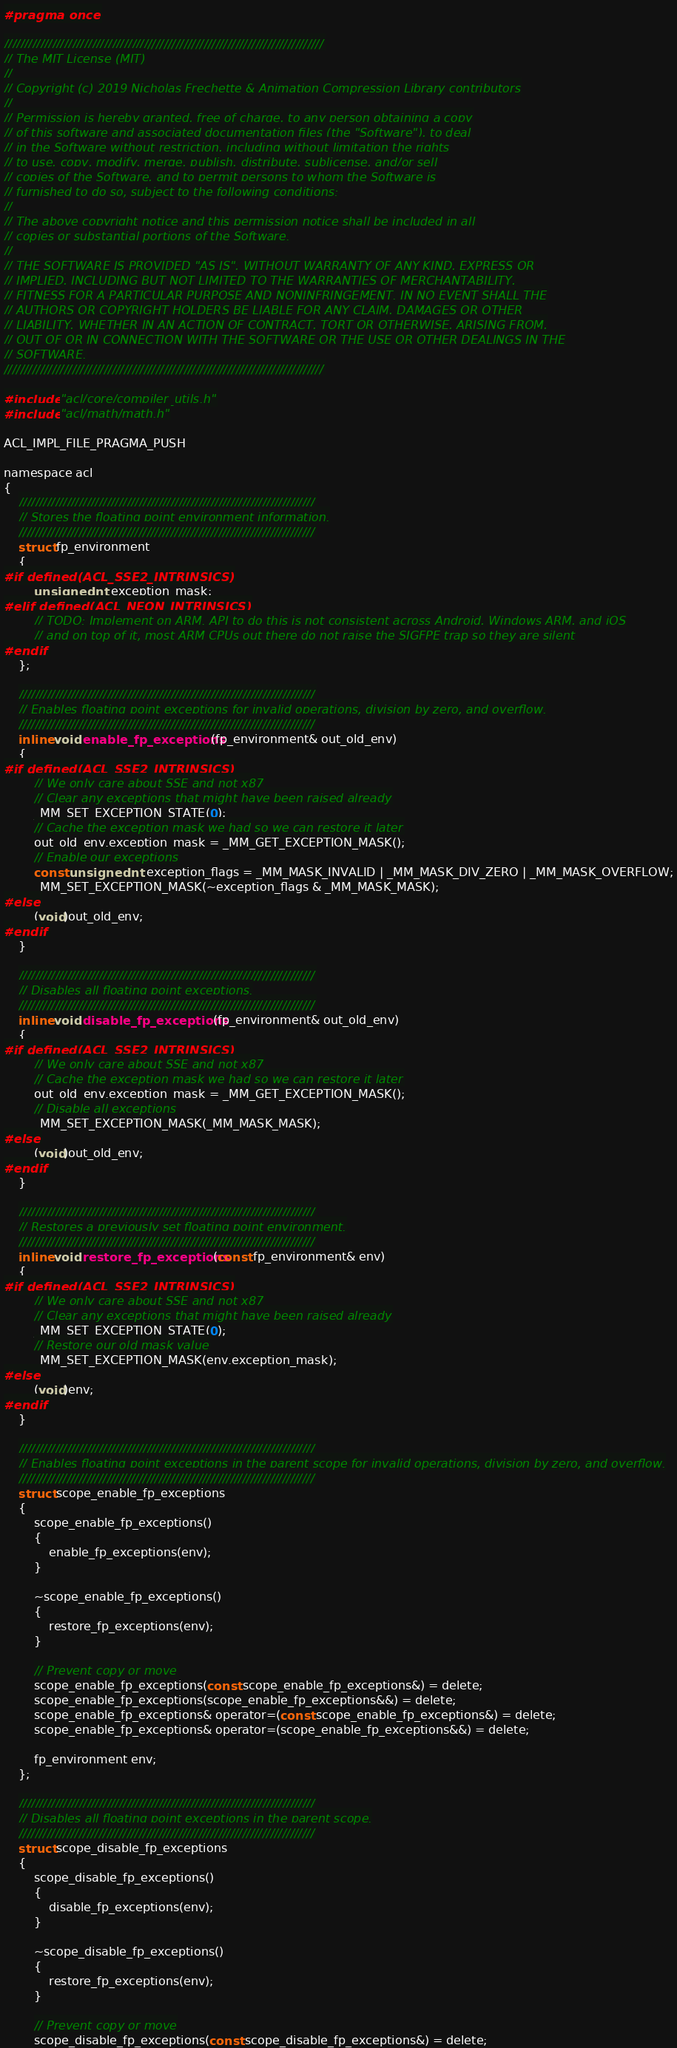Convert code to text. <code><loc_0><loc_0><loc_500><loc_500><_C_>#pragma once

////////////////////////////////////////////////////////////////////////////////
// The MIT License (MIT)
//
// Copyright (c) 2019 Nicholas Frechette & Animation Compression Library contributors
//
// Permission is hereby granted, free of charge, to any person obtaining a copy
// of this software and associated documentation files (the "Software"), to deal
// in the Software without restriction, including without limitation the rights
// to use, copy, modify, merge, publish, distribute, sublicense, and/or sell
// copies of the Software, and to permit persons to whom the Software is
// furnished to do so, subject to the following conditions:
//
// The above copyright notice and this permission notice shall be included in all
// copies or substantial portions of the Software.
//
// THE SOFTWARE IS PROVIDED "AS IS", WITHOUT WARRANTY OF ANY KIND, EXPRESS OR
// IMPLIED, INCLUDING BUT NOT LIMITED TO THE WARRANTIES OF MERCHANTABILITY,
// FITNESS FOR A PARTICULAR PURPOSE AND NONINFRINGEMENT. IN NO EVENT SHALL THE
// AUTHORS OR COPYRIGHT HOLDERS BE LIABLE FOR ANY CLAIM, DAMAGES OR OTHER
// LIABILITY, WHETHER IN AN ACTION OF CONTRACT, TORT OR OTHERWISE, ARISING FROM,
// OUT OF OR IN CONNECTION WITH THE SOFTWARE OR THE USE OR OTHER DEALINGS IN THE
// SOFTWARE.
////////////////////////////////////////////////////////////////////////////////

#include "acl/core/compiler_utils.h"
#include "acl/math/math.h"

ACL_IMPL_FILE_PRAGMA_PUSH

namespace acl
{
	//////////////////////////////////////////////////////////////////////////
	// Stores the floating point environment information.
	//////////////////////////////////////////////////////////////////////////
	struct fp_environment
	{
#if defined(ACL_SSE2_INTRINSICS)
		unsigned int exception_mask;
#elif defined(ACL_NEON_INTRINSICS)
		// TODO: Implement on ARM. API to do this is not consistent across Android, Windows ARM, and iOS
		// and on top of it, most ARM CPUs out there do not raise the SIGFPE trap so they are silent
#endif
	};

	//////////////////////////////////////////////////////////////////////////
	// Enables floating point exceptions for invalid operations, division by zero, and overflow.
	//////////////////////////////////////////////////////////////////////////
	inline void enable_fp_exceptions(fp_environment& out_old_env)
	{
#if defined(ACL_SSE2_INTRINSICS)
		// We only care about SSE and not x87
		// Clear any exceptions that might have been raised already
		_MM_SET_EXCEPTION_STATE(0);
		// Cache the exception mask we had so we can restore it later
		out_old_env.exception_mask = _MM_GET_EXCEPTION_MASK();
		// Enable our exceptions
		const unsigned int exception_flags = _MM_MASK_INVALID | _MM_MASK_DIV_ZERO | _MM_MASK_OVERFLOW;
		_MM_SET_EXCEPTION_MASK(~exception_flags & _MM_MASK_MASK);
#else
		(void)out_old_env;
#endif
	}

	//////////////////////////////////////////////////////////////////////////
	// Disables all floating point exceptions.
	//////////////////////////////////////////////////////////////////////////
	inline void disable_fp_exceptions(fp_environment& out_old_env)
	{
#if defined(ACL_SSE2_INTRINSICS)
		// We only care about SSE and not x87
		// Cache the exception mask we had so we can restore it later
		out_old_env.exception_mask = _MM_GET_EXCEPTION_MASK();
		// Disable all exceptions
		_MM_SET_EXCEPTION_MASK(_MM_MASK_MASK);
#else
		(void)out_old_env;
#endif
	}

	//////////////////////////////////////////////////////////////////////////
	// Restores a previously set floating point environment.
	//////////////////////////////////////////////////////////////////////////
	inline void restore_fp_exceptions(const fp_environment& env)
	{
#if defined(ACL_SSE2_INTRINSICS)
		// We only care about SSE and not x87
		// Clear any exceptions that might have been raised already
		_MM_SET_EXCEPTION_STATE(0);
		// Restore our old mask value
		_MM_SET_EXCEPTION_MASK(env.exception_mask);
#else
		(void)env;
#endif
	}

	//////////////////////////////////////////////////////////////////////////
	// Enables floating point exceptions in the parent scope for invalid operations, division by zero, and overflow.
	//////////////////////////////////////////////////////////////////////////
	struct scope_enable_fp_exceptions
	{
		scope_enable_fp_exceptions()
		{
			enable_fp_exceptions(env);
		}

		~scope_enable_fp_exceptions()
		{
			restore_fp_exceptions(env);
		}

		// Prevent copy or move
		scope_enable_fp_exceptions(const scope_enable_fp_exceptions&) = delete;
		scope_enable_fp_exceptions(scope_enable_fp_exceptions&&) = delete;
		scope_enable_fp_exceptions& operator=(const scope_enable_fp_exceptions&) = delete;
		scope_enable_fp_exceptions& operator=(scope_enable_fp_exceptions&&) = delete;

		fp_environment env;
	};

	//////////////////////////////////////////////////////////////////////////
	// Disables all floating point exceptions in the parent scope.
	//////////////////////////////////////////////////////////////////////////
	struct scope_disable_fp_exceptions
	{
		scope_disable_fp_exceptions()
		{
			disable_fp_exceptions(env);
		}

		~scope_disable_fp_exceptions()
		{
			restore_fp_exceptions(env);
		}

		// Prevent copy or move
		scope_disable_fp_exceptions(const scope_disable_fp_exceptions&) = delete;</code> 